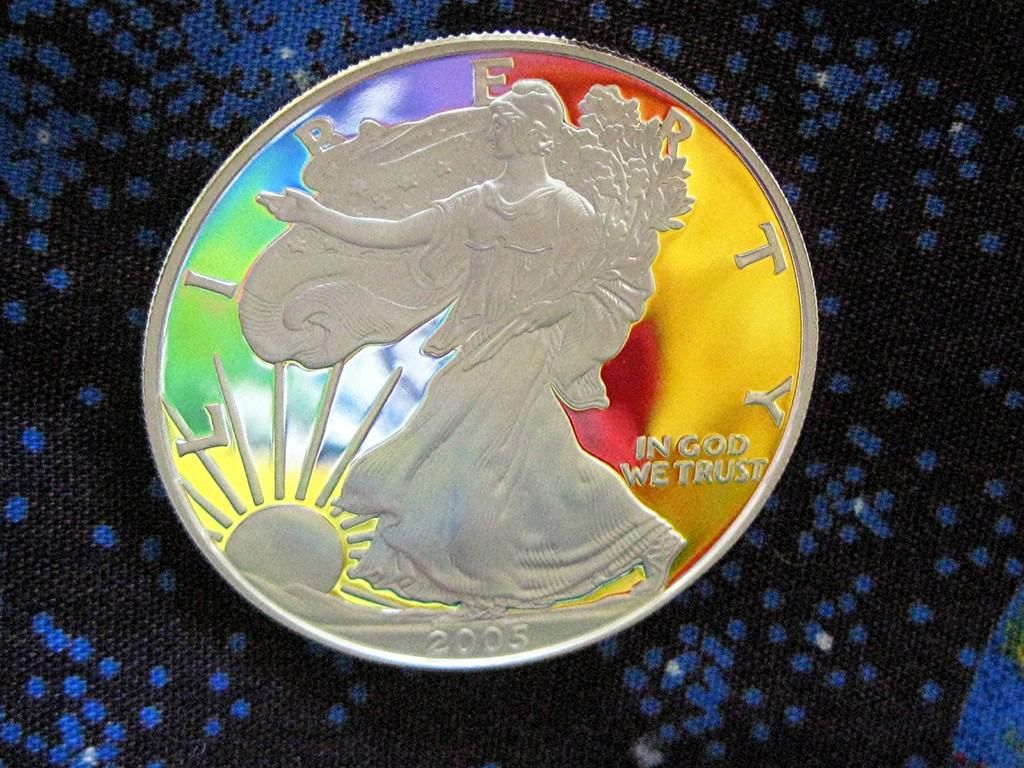Provide a one-sentence caption for the provided image. A Liberty coin has been painted with a design. 